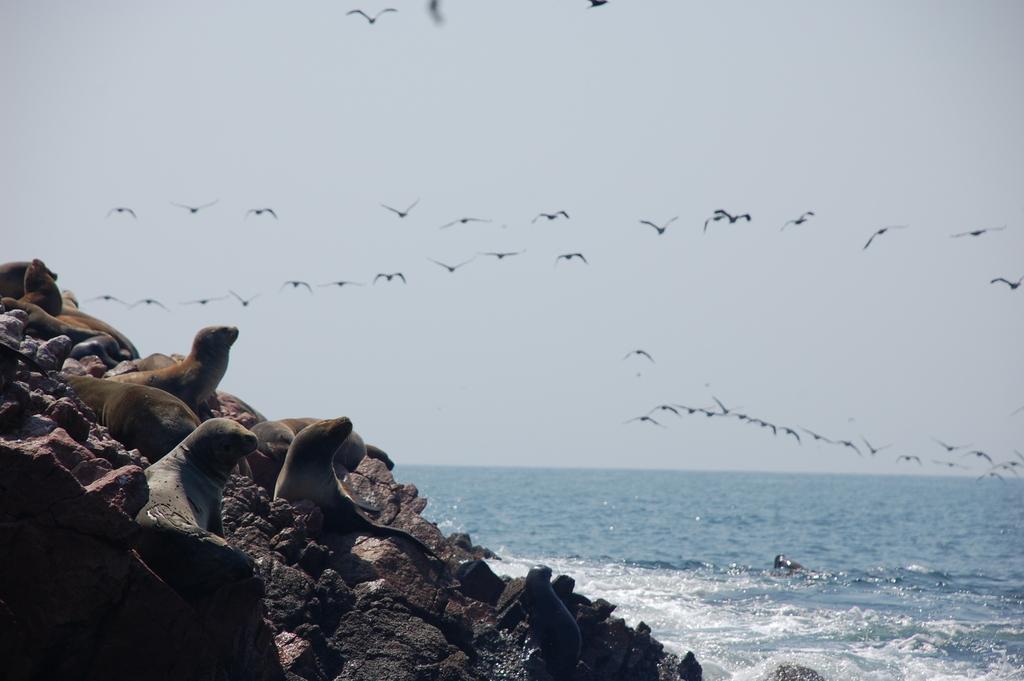How would you summarize this image in a sentence or two? On the left side we can see seals on the rocks and on the right side we can see water and there are birds flying in the air and this is the sky. 